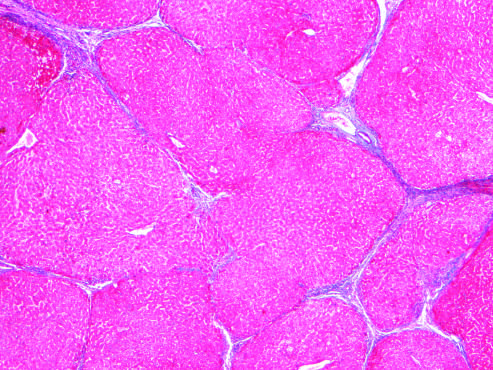when are most scars gone masson trichrome stain?
Answer the question using a single word or phrase. After 1 year of abstinence 